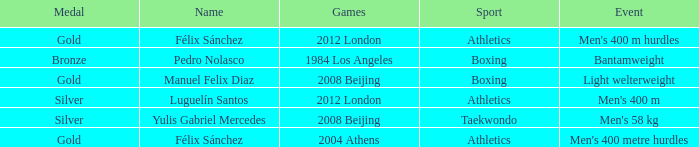Could you parse the entire table? {'header': ['Medal', 'Name', 'Games', 'Sport', 'Event'], 'rows': [['Gold', 'Félix Sánchez', '2012 London', 'Athletics', "Men's 400 m hurdles"], ['Bronze', 'Pedro Nolasco', '1984 Los Angeles', 'Boxing', 'Bantamweight'], ['Gold', 'Manuel Felix Diaz', '2008 Beijing', 'Boxing', 'Light welterweight'], ['Silver', 'Luguelín Santos', '2012 London', 'Athletics', "Men's 400 m"], ['Silver', 'Yulis Gabriel Mercedes', '2008 Beijing', 'Taekwondo', "Men's 58 kg"], ['Gold', 'Félix Sánchez', '2004 Athens', 'Athletics', "Men's 400 metre hurdles"]]} Which Name had a Games of 2008 beijing, and a Medal of gold? Manuel Felix Diaz. 